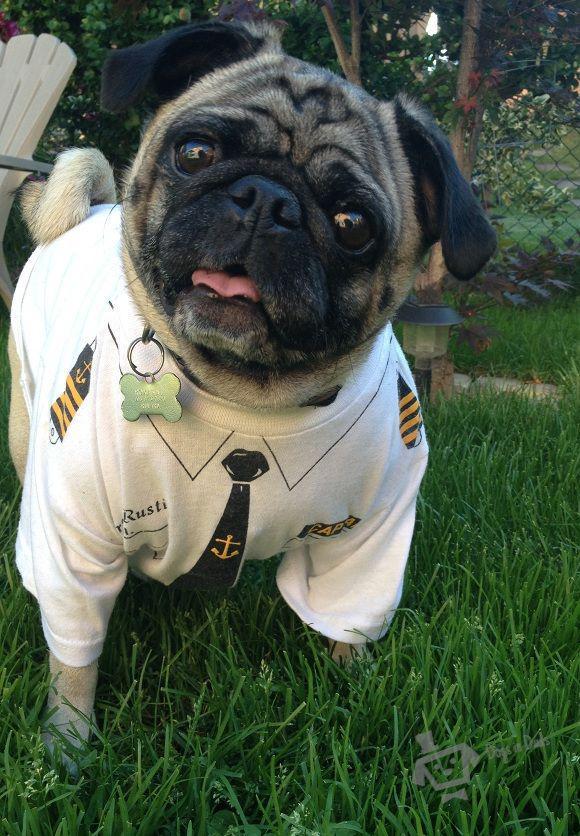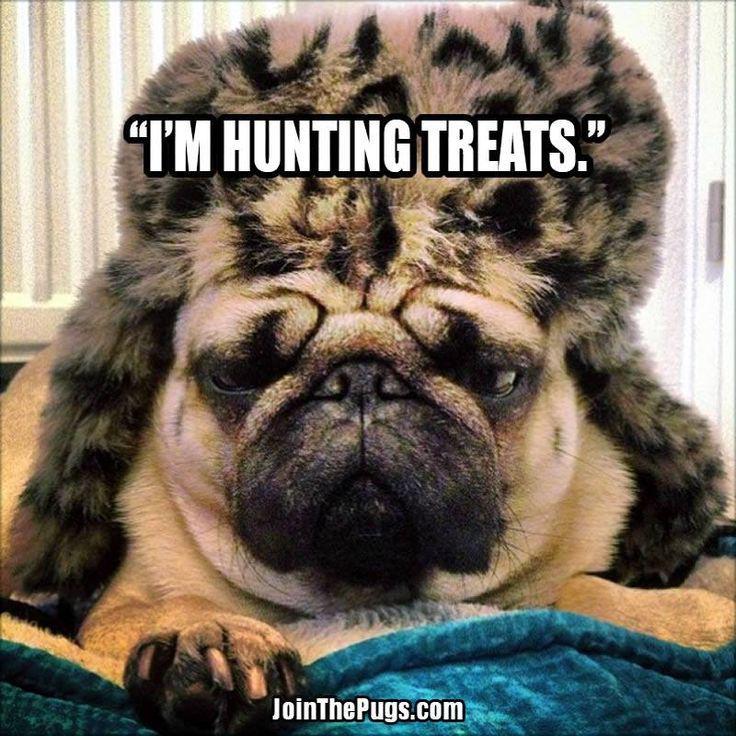The first image is the image on the left, the second image is the image on the right. Assess this claim about the two images: "There is two dogs in the right image.". Correct or not? Answer yes or no. No. The first image is the image on the left, the second image is the image on the right. Examine the images to the left and right. Is the description "One image shows a smaller black dog next to a buff-beige pug." accurate? Answer yes or no. No. 